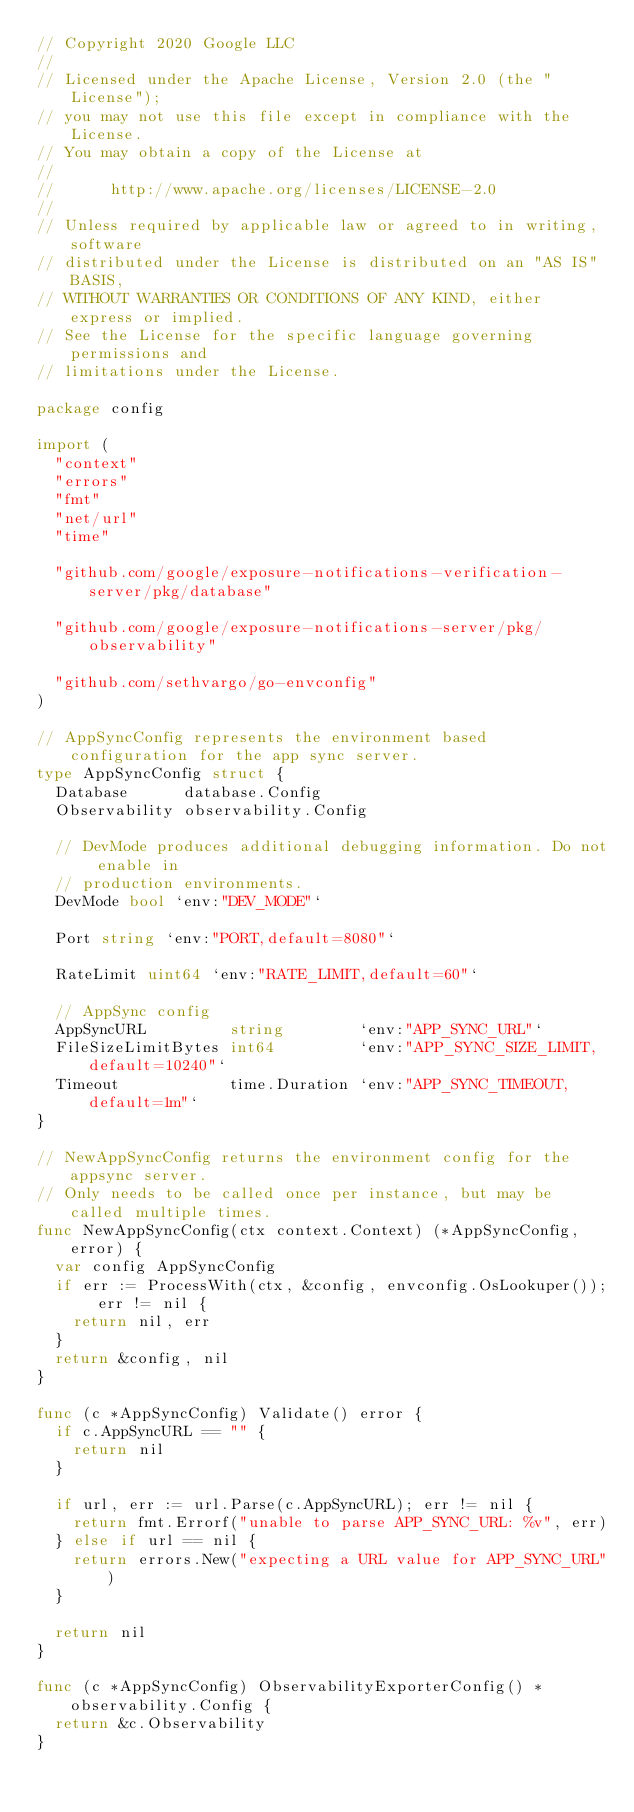Convert code to text. <code><loc_0><loc_0><loc_500><loc_500><_Go_>// Copyright 2020 Google LLC
//
// Licensed under the Apache License, Version 2.0 (the "License");
// you may not use this file except in compliance with the License.
// You may obtain a copy of the License at
//
//      http://www.apache.org/licenses/LICENSE-2.0
//
// Unless required by applicable law or agreed to in writing, software
// distributed under the License is distributed on an "AS IS" BASIS,
// WITHOUT WARRANTIES OR CONDITIONS OF ANY KIND, either express or implied.
// See the License for the specific language governing permissions and
// limitations under the License.

package config

import (
	"context"
	"errors"
	"fmt"
	"net/url"
	"time"

	"github.com/google/exposure-notifications-verification-server/pkg/database"

	"github.com/google/exposure-notifications-server/pkg/observability"

	"github.com/sethvargo/go-envconfig"
)

// AppSyncConfig represents the environment based configuration for the app sync server.
type AppSyncConfig struct {
	Database      database.Config
	Observability observability.Config

	// DevMode produces additional debugging information. Do not enable in
	// production environments.
	DevMode bool `env:"DEV_MODE"`

	Port string `env:"PORT,default=8080"`

	RateLimit uint64 `env:"RATE_LIMIT,default=60"`

	// AppSync config
	AppSyncURL         string        `env:"APP_SYNC_URL"`
	FileSizeLimitBytes int64         `env:"APP_SYNC_SIZE_LIMIT, default=10240"`
	Timeout            time.Duration `env:"APP_SYNC_TIMEOUT, default=1m"`
}

// NewAppSyncConfig returns the environment config for the appsync server.
// Only needs to be called once per instance, but may be called multiple times.
func NewAppSyncConfig(ctx context.Context) (*AppSyncConfig, error) {
	var config AppSyncConfig
	if err := ProcessWith(ctx, &config, envconfig.OsLookuper()); err != nil {
		return nil, err
	}
	return &config, nil
}

func (c *AppSyncConfig) Validate() error {
	if c.AppSyncURL == "" {
		return nil
	}

	if url, err := url.Parse(c.AppSyncURL); err != nil {
		return fmt.Errorf("unable to parse APP_SYNC_URL: %v", err)
	} else if url == nil {
		return errors.New("expecting a URL value for APP_SYNC_URL")
	}

	return nil
}

func (c *AppSyncConfig) ObservabilityExporterConfig() *observability.Config {
	return &c.Observability
}
</code> 